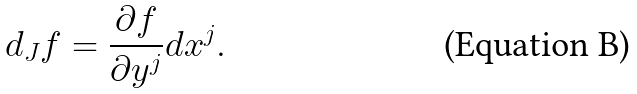<formula> <loc_0><loc_0><loc_500><loc_500>d _ { J } f = \frac { \partial f } { \partial y ^ { j } } d x ^ { j } .</formula> 